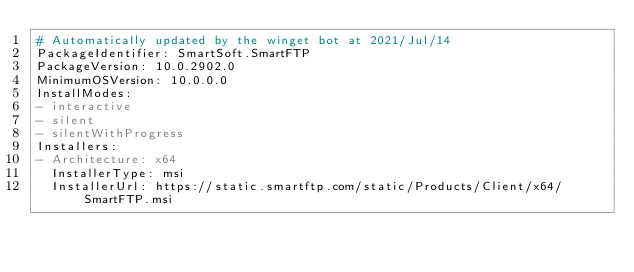<code> <loc_0><loc_0><loc_500><loc_500><_YAML_># Automatically updated by the winget bot at 2021/Jul/14
PackageIdentifier: SmartSoft.SmartFTP
PackageVersion: 10.0.2902.0
MinimumOSVersion: 10.0.0.0
InstallModes:
- interactive
- silent
- silentWithProgress
Installers:
- Architecture: x64
  InstallerType: msi
  InstallerUrl: https://static.smartftp.com/static/Products/Client/x64/SmartFTP.msi</code> 